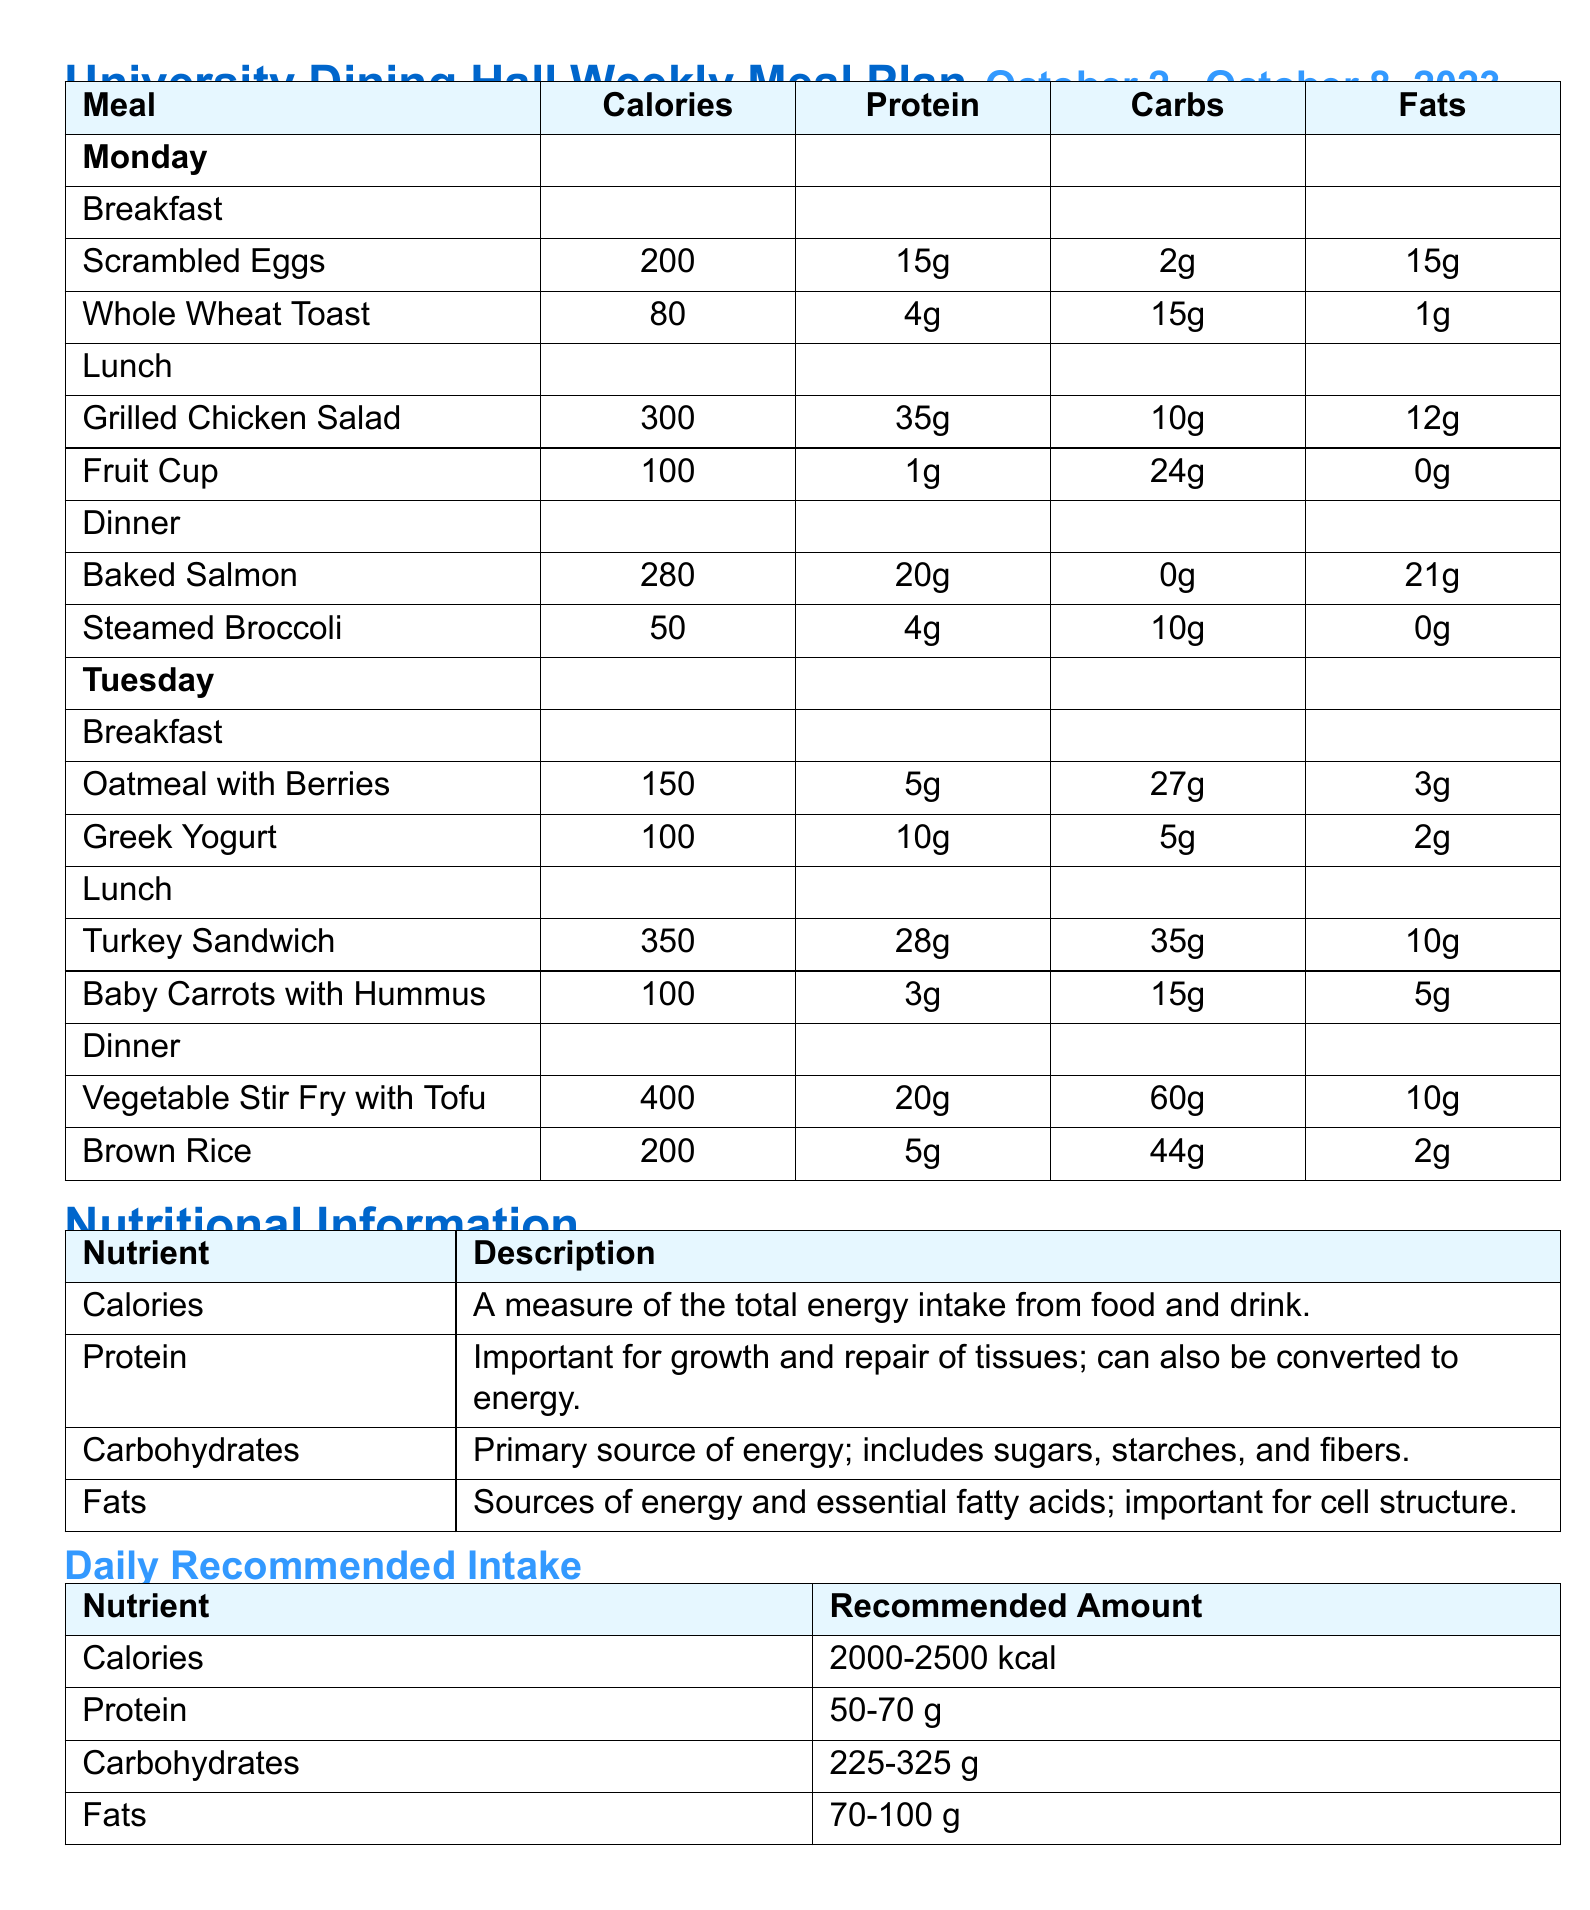What is the total calorie count for Monday's Breakfast? The total calorie count for Monday's Breakfast includes Scrambled Eggs (200) and Whole Wheat Toast (80), so 200 + 80 = 280.
Answer: 280 How many grams of protein are in the Baked Salmon? The document states that Baked Salmon contains 20 grams of protein.
Answer: 20g What is included in the Tuesday dinner? Tuesday dinner includes Vegetable Stir Fry with Tofu and Brown Rice.
Answer: Vegetable Stir Fry with Tofu and Brown Rice What is the recommended daily intake of carbohydrates? The document specifies that the recommended daily intake for carbohydrates is between 225 and 325 grams.
Answer: 225-325 g What food item has the highest calorie count on Tuesday? The food item with the highest calorie count on Tuesday is Vegetable Stir Fry with Tofu (400 calories).
Answer: 400 How many grams of fats are in the Turkey Sandwich? The Turkey Sandwich contains 10 grams of fats according to the document.
Answer: 10g What nutrient is essential for cell structure? The description in the nutritional information highlights fats as essential for cell structure.
Answer: Fats What is the calorie content of the Grilled Chicken Salad? The document lists the Grilled Chicken Salad's calorie content as 300 calories.
Answer: 300 Which day has Steamed Broccoli in its meal plan? The meal plan shows that Steamed Broccoli is included in Monday's dinner.
Answer: Monday 